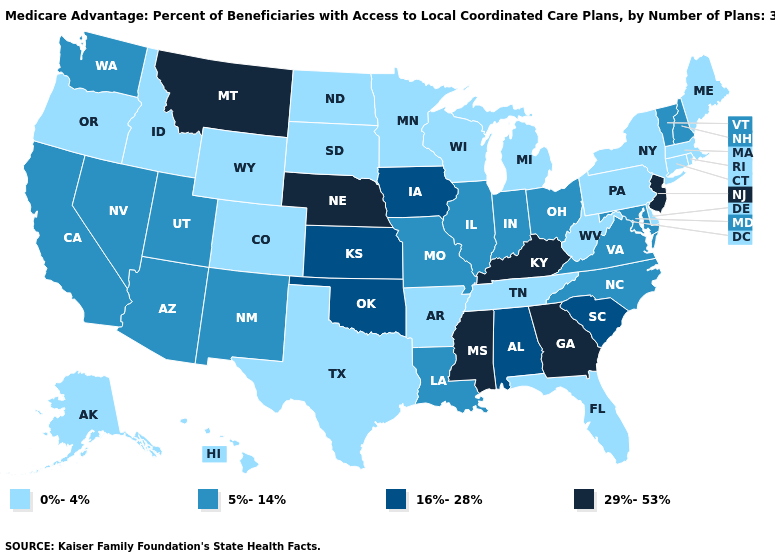Name the states that have a value in the range 5%-14%?
Short answer required. California, Illinois, Indiana, Louisiana, Maryland, Missouri, North Carolina, New Hampshire, New Mexico, Nevada, Ohio, Utah, Virginia, Vermont, Washington, Arizona. Name the states that have a value in the range 29%-53%?
Keep it brief. Georgia, Kentucky, Mississippi, Montana, Nebraska, New Jersey. What is the value of Hawaii?
Keep it brief. 0%-4%. What is the value of South Dakota?
Answer briefly. 0%-4%. Is the legend a continuous bar?
Be succinct. No. How many symbols are there in the legend?
Short answer required. 4. Does the first symbol in the legend represent the smallest category?
Concise answer only. Yes. What is the value of Oregon?
Write a very short answer. 0%-4%. Does the first symbol in the legend represent the smallest category?
Be succinct. Yes. Does the map have missing data?
Short answer required. No. Name the states that have a value in the range 29%-53%?
Give a very brief answer. Georgia, Kentucky, Mississippi, Montana, Nebraska, New Jersey. Does the first symbol in the legend represent the smallest category?
Be succinct. Yes. Name the states that have a value in the range 29%-53%?
Quick response, please. Georgia, Kentucky, Mississippi, Montana, Nebraska, New Jersey. Which states have the highest value in the USA?
Keep it brief. Georgia, Kentucky, Mississippi, Montana, Nebraska, New Jersey. Name the states that have a value in the range 0%-4%?
Be succinct. Colorado, Connecticut, Delaware, Florida, Hawaii, Idaho, Massachusetts, Maine, Michigan, Minnesota, North Dakota, New York, Oregon, Pennsylvania, Rhode Island, South Dakota, Alaska, Tennessee, Texas, Wisconsin, West Virginia, Wyoming, Arkansas. 